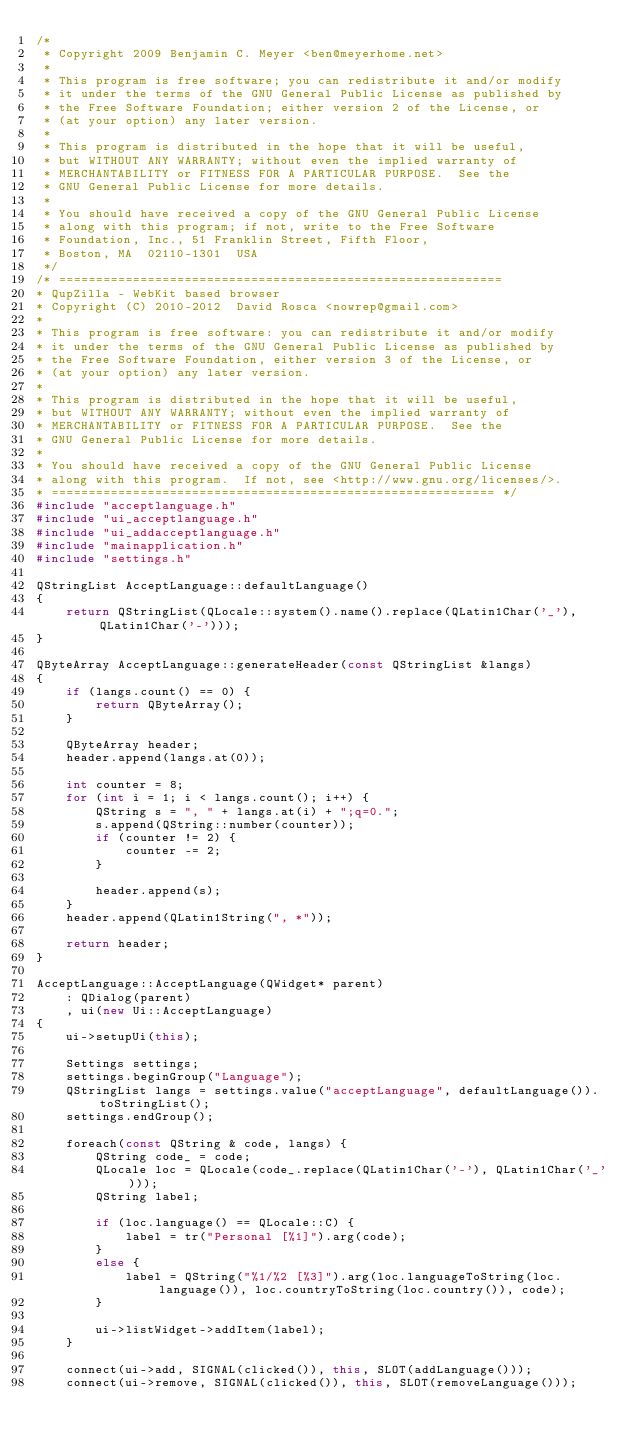Convert code to text. <code><loc_0><loc_0><loc_500><loc_500><_C++_>/*
 * Copyright 2009 Benjamin C. Meyer <ben@meyerhome.net>
 *
 * This program is free software; you can redistribute it and/or modify
 * it under the terms of the GNU General Public License as published by
 * the Free Software Foundation; either version 2 of the License, or
 * (at your option) any later version.
 *
 * This program is distributed in the hope that it will be useful,
 * but WITHOUT ANY WARRANTY; without even the implied warranty of
 * MERCHANTABILITY or FITNESS FOR A PARTICULAR PURPOSE.  See the
 * GNU General Public License for more details.
 *
 * You should have received a copy of the GNU General Public License
 * along with this program; if not, write to the Free Software
 * Foundation, Inc., 51 Franklin Street, Fifth Floor,
 * Boston, MA  02110-1301  USA
 */
/* ============================================================
* QupZilla - WebKit based browser
* Copyright (C) 2010-2012  David Rosca <nowrep@gmail.com>
*
* This program is free software: you can redistribute it and/or modify
* it under the terms of the GNU General Public License as published by
* the Free Software Foundation, either version 3 of the License, or
* (at your option) any later version.
*
* This program is distributed in the hope that it will be useful,
* but WITHOUT ANY WARRANTY; without even the implied warranty of
* MERCHANTABILITY or FITNESS FOR A PARTICULAR PURPOSE.  See the
* GNU General Public License for more details.
*
* You should have received a copy of the GNU General Public License
* along with this program.  If not, see <http://www.gnu.org/licenses/>.
* ============================================================ */
#include "acceptlanguage.h"
#include "ui_acceptlanguage.h"
#include "ui_addacceptlanguage.h"
#include "mainapplication.h"
#include "settings.h"

QStringList AcceptLanguage::defaultLanguage()
{
    return QStringList(QLocale::system().name().replace(QLatin1Char('_'), QLatin1Char('-')));
}

QByteArray AcceptLanguage::generateHeader(const QStringList &langs)
{
    if (langs.count() == 0) {
        return QByteArray();
    }

    QByteArray header;
    header.append(langs.at(0));

    int counter = 8;
    for (int i = 1; i < langs.count(); i++) {
        QString s = ", " + langs.at(i) + ";q=0.";
        s.append(QString::number(counter));
        if (counter != 2) {
            counter -= 2;
        }

        header.append(s);
    }
    header.append(QLatin1String(", *"));

    return header;
}

AcceptLanguage::AcceptLanguage(QWidget* parent)
    : QDialog(parent)
    , ui(new Ui::AcceptLanguage)
{
    ui->setupUi(this);

    Settings settings;
    settings.beginGroup("Language");
    QStringList langs = settings.value("acceptLanguage", defaultLanguage()).toStringList();
    settings.endGroup();

    foreach(const QString & code, langs) {
        QString code_ = code;
        QLocale loc = QLocale(code_.replace(QLatin1Char('-'), QLatin1Char('_')));
        QString label;

        if (loc.language() == QLocale::C) {
            label = tr("Personal [%1]").arg(code);
        }
        else {
            label = QString("%1/%2 [%3]").arg(loc.languageToString(loc.language()), loc.countryToString(loc.country()), code);
        }

        ui->listWidget->addItem(label);
    }

    connect(ui->add, SIGNAL(clicked()), this, SLOT(addLanguage()));
    connect(ui->remove, SIGNAL(clicked()), this, SLOT(removeLanguage()));</code> 